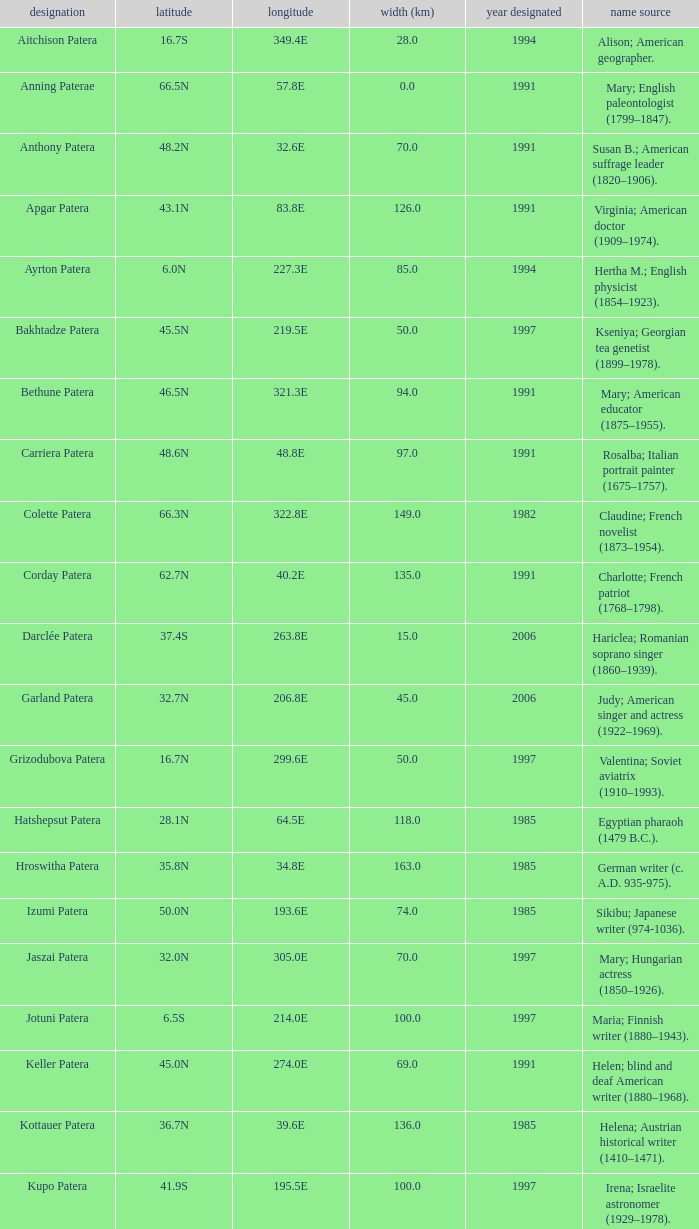In what year was the feature at a 33.3S latitude named?  2000.0. 